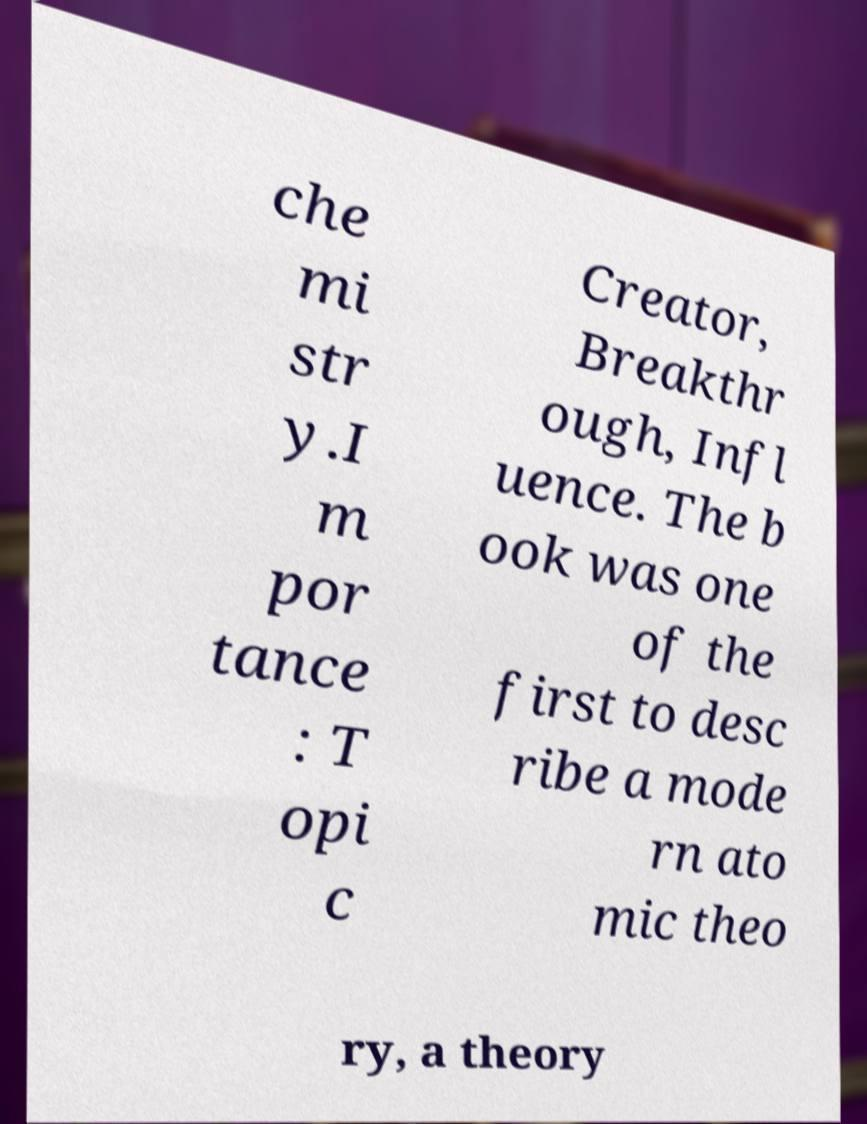There's text embedded in this image that I need extracted. Can you transcribe it verbatim? che mi str y.I m por tance : T opi c Creator, Breakthr ough, Infl uence. The b ook was one of the first to desc ribe a mode rn ato mic theo ry, a theory 